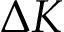Convert formula to latex. <formula><loc_0><loc_0><loc_500><loc_500>\Delta K</formula> 